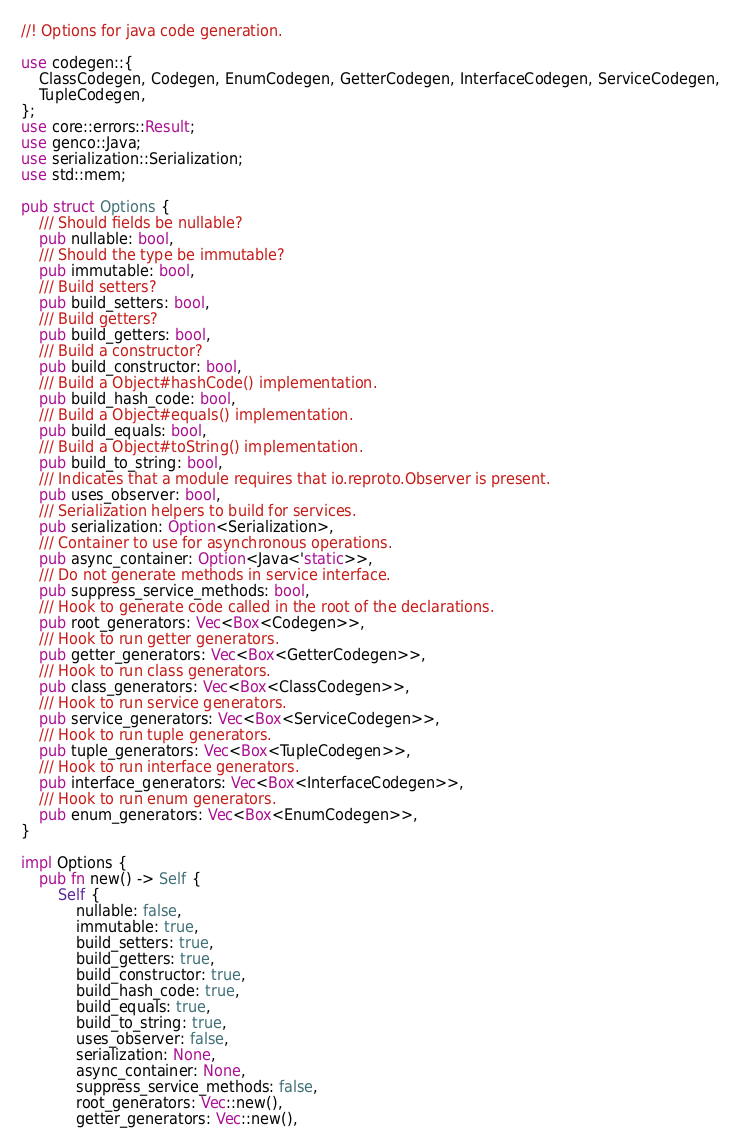Convert code to text. <code><loc_0><loc_0><loc_500><loc_500><_Rust_>//! Options for java code generation.

use codegen::{
    ClassCodegen, Codegen, EnumCodegen, GetterCodegen, InterfaceCodegen, ServiceCodegen,
    TupleCodegen,
};
use core::errors::Result;
use genco::Java;
use serialization::Serialization;
use std::mem;

pub struct Options {
    /// Should fields be nullable?
    pub nullable: bool,
    /// Should the type be immutable?
    pub immutable: bool,
    /// Build setters?
    pub build_setters: bool,
    /// Build getters?
    pub build_getters: bool,
    /// Build a constructor?
    pub build_constructor: bool,
    /// Build a Object#hashCode() implementation.
    pub build_hash_code: bool,
    /// Build a Object#equals() implementation.
    pub build_equals: bool,
    /// Build a Object#toString() implementation.
    pub build_to_string: bool,
    /// Indicates that a module requires that io.reproto.Observer is present.
    pub uses_observer: bool,
    /// Serialization helpers to build for services.
    pub serialization: Option<Serialization>,
    /// Container to use for asynchronous operations.
    pub async_container: Option<Java<'static>>,
    /// Do not generate methods in service interface.
    pub suppress_service_methods: bool,
    /// Hook to generate code called in the root of the declarations.
    pub root_generators: Vec<Box<Codegen>>,
    /// Hook to run getter generators.
    pub getter_generators: Vec<Box<GetterCodegen>>,
    /// Hook to run class generators.
    pub class_generators: Vec<Box<ClassCodegen>>,
    /// Hook to run service generators.
    pub service_generators: Vec<Box<ServiceCodegen>>,
    /// Hook to run tuple generators.
    pub tuple_generators: Vec<Box<TupleCodegen>>,
    /// Hook to run interface generators.
    pub interface_generators: Vec<Box<InterfaceCodegen>>,
    /// Hook to run enum generators.
    pub enum_generators: Vec<Box<EnumCodegen>>,
}

impl Options {
    pub fn new() -> Self {
        Self {
            nullable: false,
            immutable: true,
            build_setters: true,
            build_getters: true,
            build_constructor: true,
            build_hash_code: true,
            build_equals: true,
            build_to_string: true,
            uses_observer: false,
            serialization: None,
            async_container: None,
            suppress_service_methods: false,
            root_generators: Vec::new(),
            getter_generators: Vec::new(),</code> 